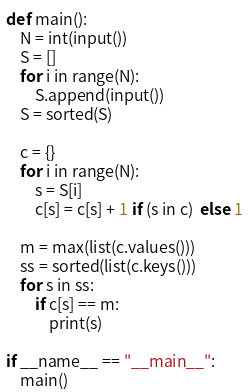Convert code to text. <code><loc_0><loc_0><loc_500><loc_500><_Python_>def main():
    N = int(input())
    S = []
    for i in range(N):
        S.append(input())
    S = sorted(S)

    c = {}
    for i in range(N):
        s = S[i]
        c[s] = c[s] + 1 if (s in c)  else 1

    m = max(list(c.values()))
    ss = sorted(list(c.keys()))
    for s in ss:
        if c[s] == m:
            print(s)

if __name__ == "__main__":
    main()</code> 